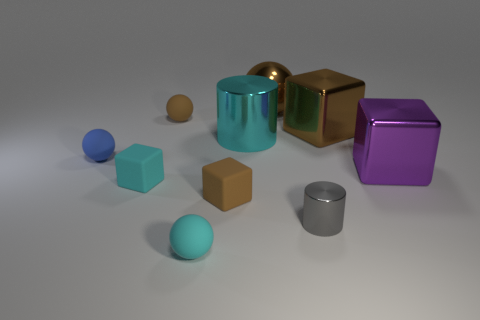Subtract all cubes. How many objects are left? 6 Add 7 blue metal spheres. How many blue metal spheres exist? 7 Subtract 1 brown cubes. How many objects are left? 9 Subtract all purple metallic things. Subtract all blue rubber balls. How many objects are left? 8 Add 6 purple blocks. How many purple blocks are left? 7 